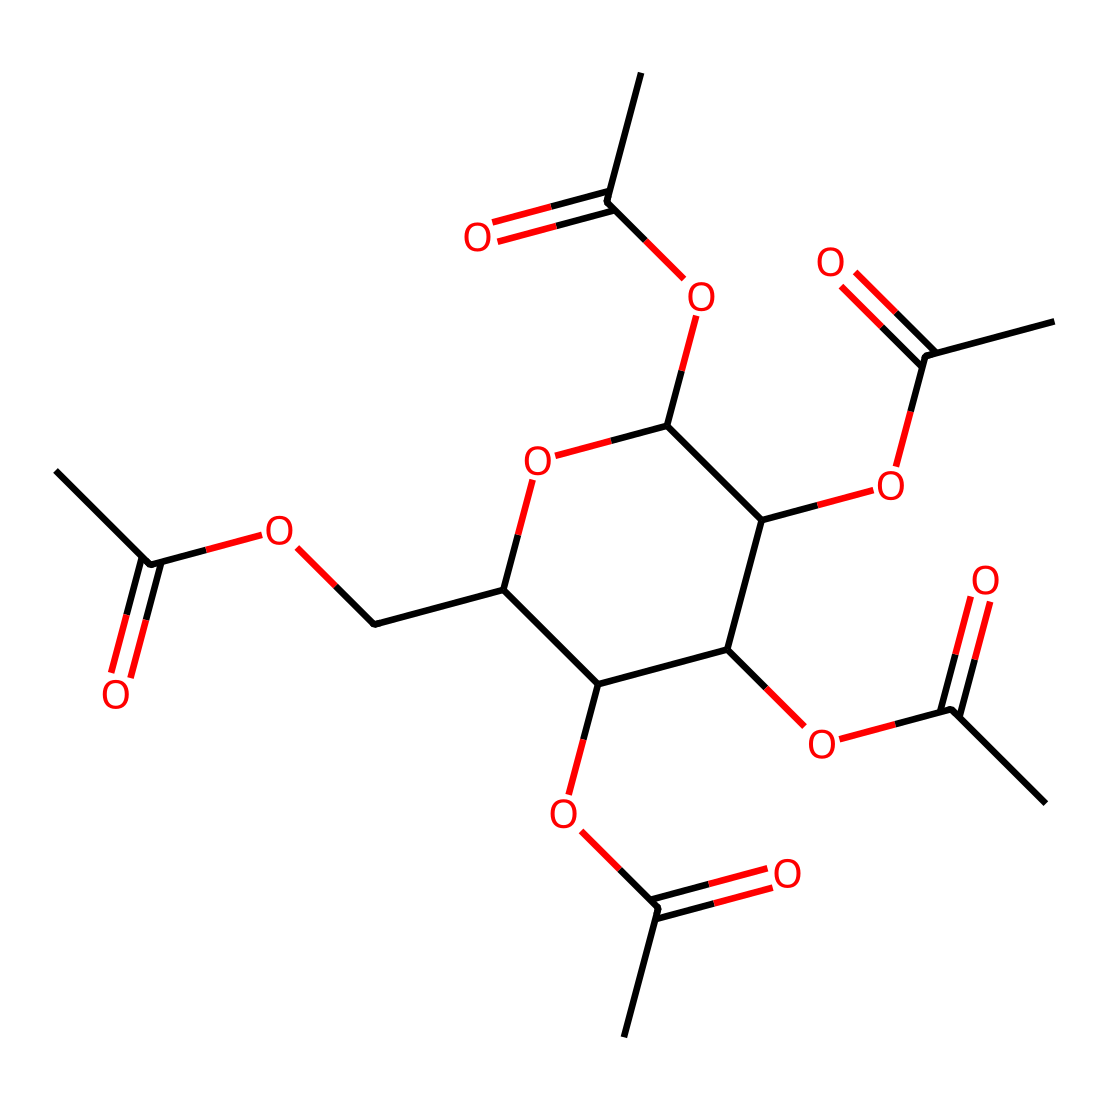What is the molecular formula of cellulose acetate? By analyzing the SMILES representation and counting the different types of atoms, it can be determined that the molecular formula is C12H20O8.
Answer: C12H20O8 How many carbon atoms are present in cellulose acetate? The chemical structure describes a series of carbon atoms represented in the SMILES notation, and counting shows there are 12 carbon atoms present.
Answer: 12 What functional group is prominent in cellulose acetate? The presence of the "OCC" and "OC(C)=O" segments indicates that the acetate functional group (-O-C=O) is a prominent feature of the molecule, characterizing its properties.
Answer: acetate How many ether linkages are found in cellulose acetate? By breaking down the structure, we observe multiple occurrences of the ether-type connection where oxygen connects two carbon atoms, identifying 5 ether linkages in total.
Answer: 5 What is the degree of polymerization for cellulose acetate derived from its structure? Analyzing the branches and repeating units through the SMILES, it can be inferred that cellulose acetate has a degree of polymerization of 3 based on the repeating units.
Answer: 3 What type of polymer is cellulose acetate categorized as? Since cellulose acetate is primarily derived from cellulose and consists of ester linkages, it falls under the category of synthetic and semi-synthetic polymers.
Answer: semi-synthetic polymer What role does the acetate group play in the properties of cellulose acetate? The acetate group provides increased solubility and film-forming capabilities, making it crucial for applications in tapes, enhancing its usability.
Answer: enhances solubility 